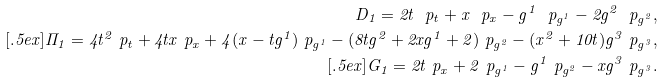Convert formula to latex. <formula><loc_0><loc_0><loc_500><loc_500>D _ { 1 } = 2 t \ p _ { t } + x \ p _ { x } - g ^ { 1 } \ p _ { g ^ { 1 } } - 2 g ^ { 2 } \ p _ { g ^ { 2 } } , \\ [ . 5 e x ] \Pi _ { 1 } = 4 t ^ { 2 } \ p _ { t } + 4 t x \ p _ { x } + 4 ( x - t g ^ { 1 } ) \ p _ { g ^ { 1 } } - ( 8 t g ^ { 2 } + 2 x g ^ { 1 } + 2 ) \ p _ { g ^ { 2 } } - ( x ^ { 2 } + 1 0 t ) g ^ { 3 } \ p _ { g ^ { 3 } } , \\ [ . 5 e x ] G _ { 1 } = 2 t \ p _ { x } + 2 \ p _ { g ^ { 1 } } - g ^ { 1 } \ p _ { g ^ { 2 } } - x g ^ { 3 } \ p _ { g ^ { 3 } } .</formula> 